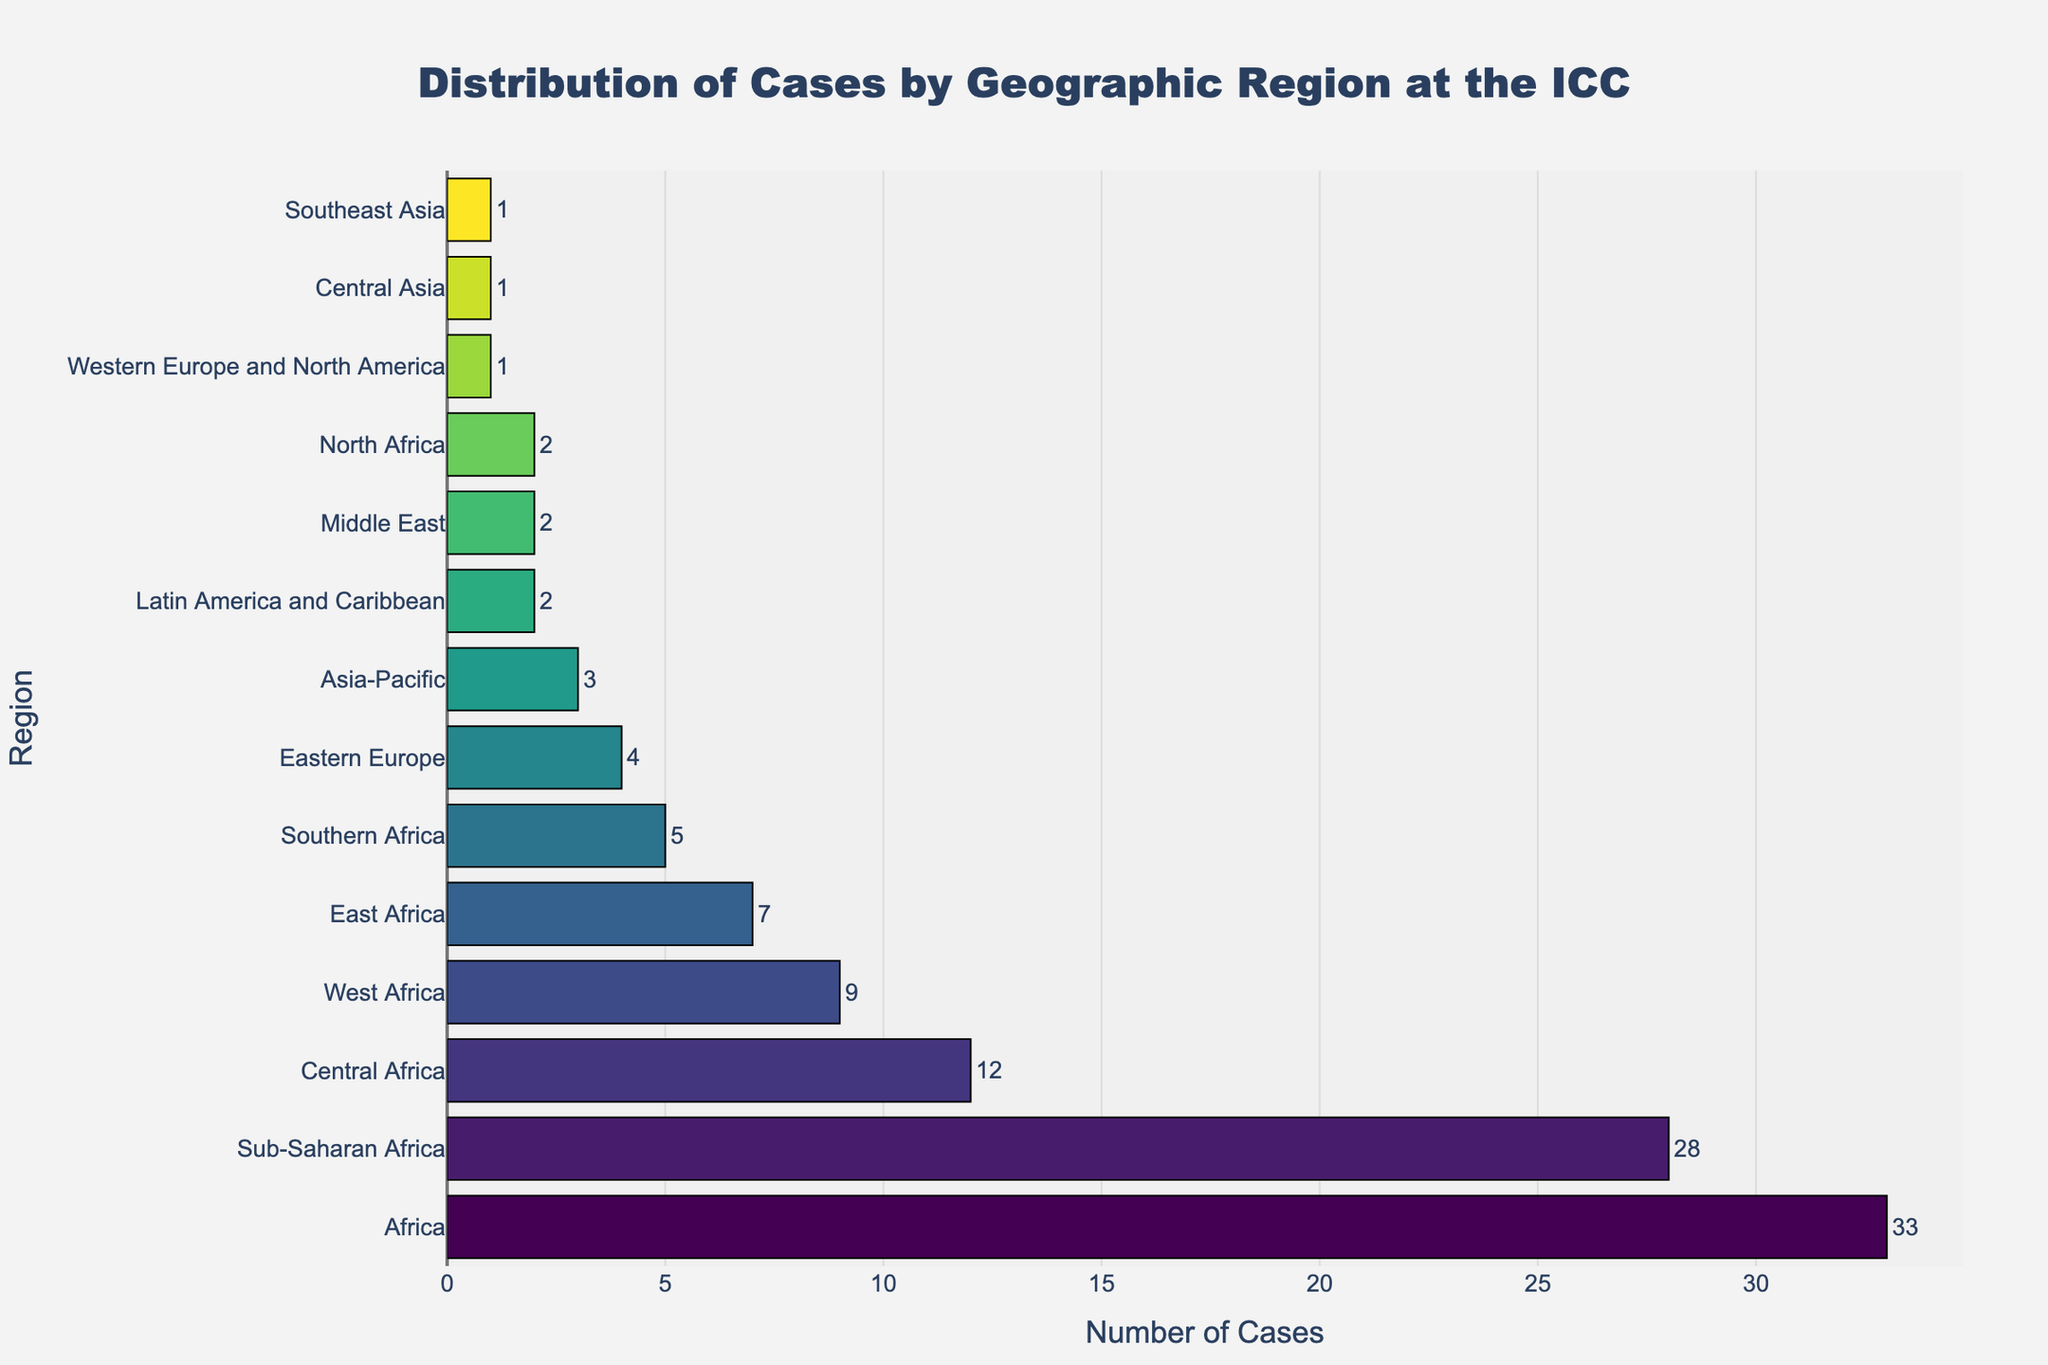Which region has the highest number of cases? The bar chart shows that "Africa" has the highest bar, indicating the highest number of cases.
Answer: Africa How many more cases does Sub-Saharan Africa have compared to Southern Africa? Sub-Saharan Africa has 28 cases, and Southern Africa has 5 cases. The difference is 28 - 5 = 23.
Answer: 23 What is the total number of cases in all African regions combined? Adding the cases from Africa (33), Sub-Saharan Africa (28), Central Africa (12), West Africa (9), East Africa (7), and Southern Africa (5): 33 + 28 + 12 + 9 + 7 + 5 = 94.
Answer: 94 Which regions have fewer than 5 cases? The regions with fewer than 5 cases are Asia-Pacific (3), Latin America and Caribbean (2), Western Europe and North America (1), Middle East (2), Central Asia (1), Southeast Asia (1), and North Africa (2).
Answer: Asia-Pacific, Latin America and Caribbean, Western Europe and North America, Middle East, Central Asia, Southeast Asia, North Africa How does the number of cases in Eastern Europe compare to that in West Africa? Eastern Europe has 4 cases, and West Africa has 9 cases. Since 4 < 9, Eastern Europe has fewer cases.
Answer: Eastern Europe has fewer cases What is the median number of cases across all regions? Listing the number of cases in ascending order: 1, 1, 2, 2, 2, 3, 4, 5, 7, 9, 12, 28, 33. The median is the middle number in the ordered list, which is 4.
Answer: 4 What is the total number of cases outside the African regions? Total cases excluding Africa (33), Sub-Saharan Africa (28), Central Africa (12), West Africa (9), East Africa (7), and Southern Africa (5) are: 3 (Asia-Pacific) + 4 (Eastern Europe) + 2 (Latin America and Caribbean) + 1 (Western Europe and North America) + 2 (Middle East) + 1 (Central Asia) + 1 (Southeast Asia) + 2 (North Africa) = 16.
Answer: 16 Which region represented by green has the most number of cases? The "green" color is part of a color gradient, so the exact tone may vary; however, "Central Africa" among similar tones shows a high number of cases in the green spectrum.
Answer: Central Africa 